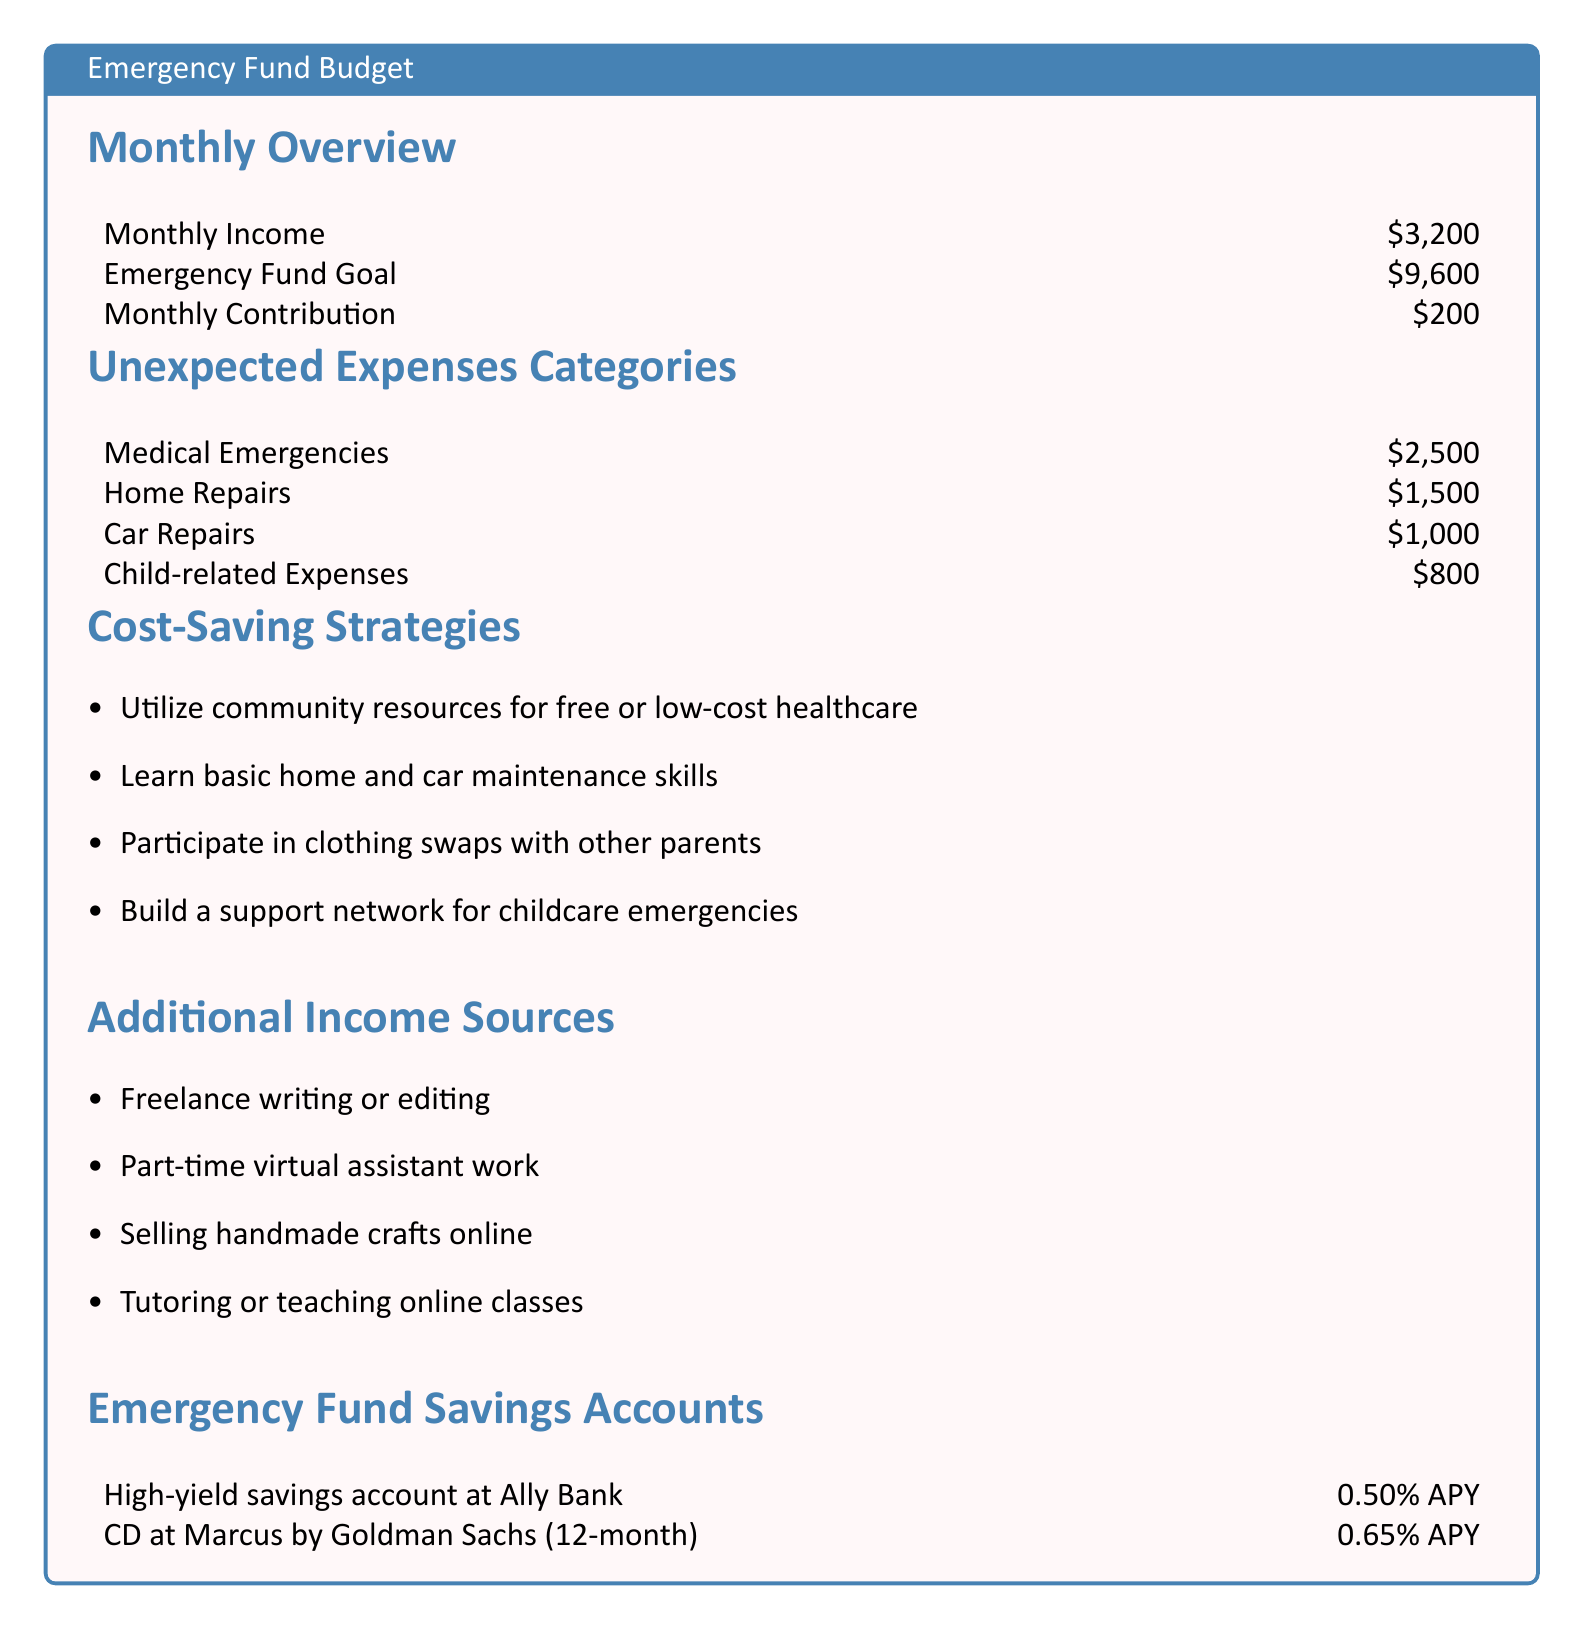what is the monthly income? The monthly income is clearly stated in the document as $3,200.
Answer: $3,200 what is the total emergency fund goal? The emergency fund goal is specified as $9,600 in the document.
Answer: $9,600 how much is allocated for medical emergencies? The document lists medical emergencies as $2,500 under unexpected expenses categories.
Answer: $2,500 what is the monthly contribution to the emergency fund? The monthly contribution amount is given as $200 in the document.
Answer: $200 how many categories of unexpected expenses are listed? The document contains four categories of unexpected expenses.
Answer: 4 which bank offers a high-yield savings account? The document mentions Ally Bank as an institution for a high-yield savings account.
Answer: Ally Bank what is one suggested cost-saving strategy? The document lists several cost-saving strategies; one example is utilizing community resources for free or low-cost healthcare.
Answer: Utilize community resources how much is budgeted for child-related expenses? The document specifies that child-related expenses are $800.
Answer: $800 what’s the APY for the CD at Marcus by Goldman Sachs? The document states that the APY for the CD at Marcus by Goldman Sachs is 0.65%.
Answer: 0.65% what type of additional income source is mentioned? The document lists several additional income sources, one of which is freelance writing or editing.
Answer: Freelance writing or editing 